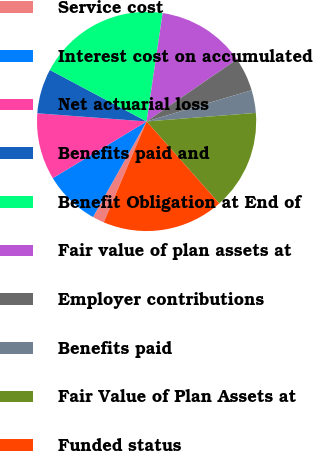Convert chart. <chart><loc_0><loc_0><loc_500><loc_500><pie_chart><fcel>Service cost<fcel>Interest cost on accumulated<fcel>Net actuarial loss<fcel>Benefits paid and<fcel>Benefit Obligation at End of<fcel>Fair value of plan assets at<fcel>Employer contributions<fcel>Benefits paid<fcel>Fair Value of Plan Assets at<fcel>Funded status<nl><fcel>1.74%<fcel>8.22%<fcel>9.84%<fcel>6.6%<fcel>19.55%<fcel>13.08%<fcel>4.98%<fcel>3.36%<fcel>14.7%<fcel>17.93%<nl></chart> 